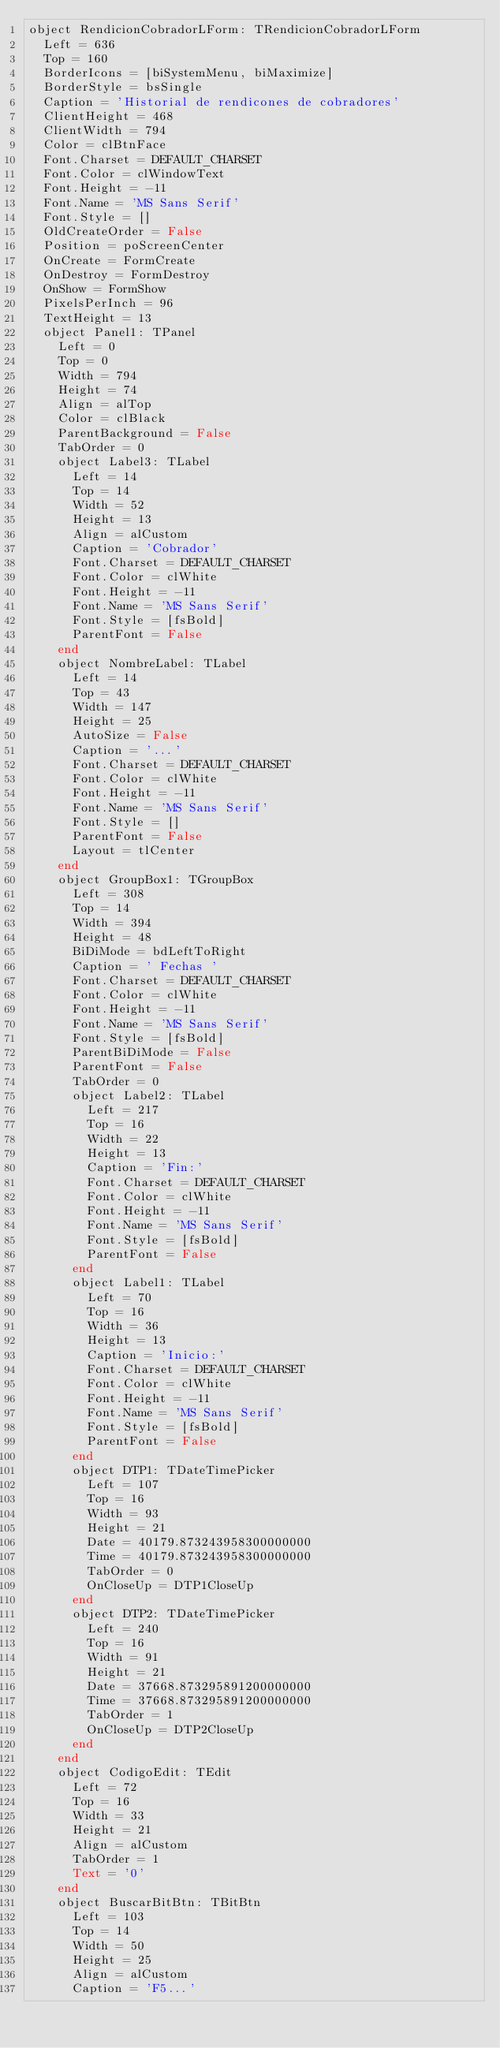Convert code to text. <code><loc_0><loc_0><loc_500><loc_500><_Pascal_>object RendicionCobradorLForm: TRendicionCobradorLForm
  Left = 636
  Top = 160
  BorderIcons = [biSystemMenu, biMaximize]
  BorderStyle = bsSingle
  Caption = 'Historial de rendicones de cobradores'
  ClientHeight = 468
  ClientWidth = 794
  Color = clBtnFace
  Font.Charset = DEFAULT_CHARSET
  Font.Color = clWindowText
  Font.Height = -11
  Font.Name = 'MS Sans Serif'
  Font.Style = []
  OldCreateOrder = False
  Position = poScreenCenter
  OnCreate = FormCreate
  OnDestroy = FormDestroy
  OnShow = FormShow
  PixelsPerInch = 96
  TextHeight = 13
  object Panel1: TPanel
    Left = 0
    Top = 0
    Width = 794
    Height = 74
    Align = alTop
    Color = clBlack
    ParentBackground = False
    TabOrder = 0
    object Label3: TLabel
      Left = 14
      Top = 14
      Width = 52
      Height = 13
      Align = alCustom
      Caption = 'Cobrador'
      Font.Charset = DEFAULT_CHARSET
      Font.Color = clWhite
      Font.Height = -11
      Font.Name = 'MS Sans Serif'
      Font.Style = [fsBold]
      ParentFont = False
    end
    object NombreLabel: TLabel
      Left = 14
      Top = 43
      Width = 147
      Height = 25
      AutoSize = False
      Caption = '...'
      Font.Charset = DEFAULT_CHARSET
      Font.Color = clWhite
      Font.Height = -11
      Font.Name = 'MS Sans Serif'
      Font.Style = []
      ParentFont = False
      Layout = tlCenter
    end
    object GroupBox1: TGroupBox
      Left = 308
      Top = 14
      Width = 394
      Height = 48
      BiDiMode = bdLeftToRight
      Caption = ' Fechas '
      Font.Charset = DEFAULT_CHARSET
      Font.Color = clWhite
      Font.Height = -11
      Font.Name = 'MS Sans Serif'
      Font.Style = [fsBold]
      ParentBiDiMode = False
      ParentFont = False
      TabOrder = 0
      object Label2: TLabel
        Left = 217
        Top = 16
        Width = 22
        Height = 13
        Caption = 'Fin:'
        Font.Charset = DEFAULT_CHARSET
        Font.Color = clWhite
        Font.Height = -11
        Font.Name = 'MS Sans Serif'
        Font.Style = [fsBold]
        ParentFont = False
      end
      object Label1: TLabel
        Left = 70
        Top = 16
        Width = 36
        Height = 13
        Caption = 'Inicio:'
        Font.Charset = DEFAULT_CHARSET
        Font.Color = clWhite
        Font.Height = -11
        Font.Name = 'MS Sans Serif'
        Font.Style = [fsBold]
        ParentFont = False
      end
      object DTP1: TDateTimePicker
        Left = 107
        Top = 16
        Width = 93
        Height = 21
        Date = 40179.873243958300000000
        Time = 40179.873243958300000000
        TabOrder = 0
        OnCloseUp = DTP1CloseUp
      end
      object DTP2: TDateTimePicker
        Left = 240
        Top = 16
        Width = 91
        Height = 21
        Date = 37668.873295891200000000
        Time = 37668.873295891200000000
        TabOrder = 1
        OnCloseUp = DTP2CloseUp
      end
    end
    object CodigoEdit: TEdit
      Left = 72
      Top = 16
      Width = 33
      Height = 21
      Align = alCustom
      TabOrder = 1
      Text = '0'
    end
    object BuscarBitBtn: TBitBtn
      Left = 103
      Top = 14
      Width = 50
      Height = 25
      Align = alCustom
      Caption = 'F5...'</code> 